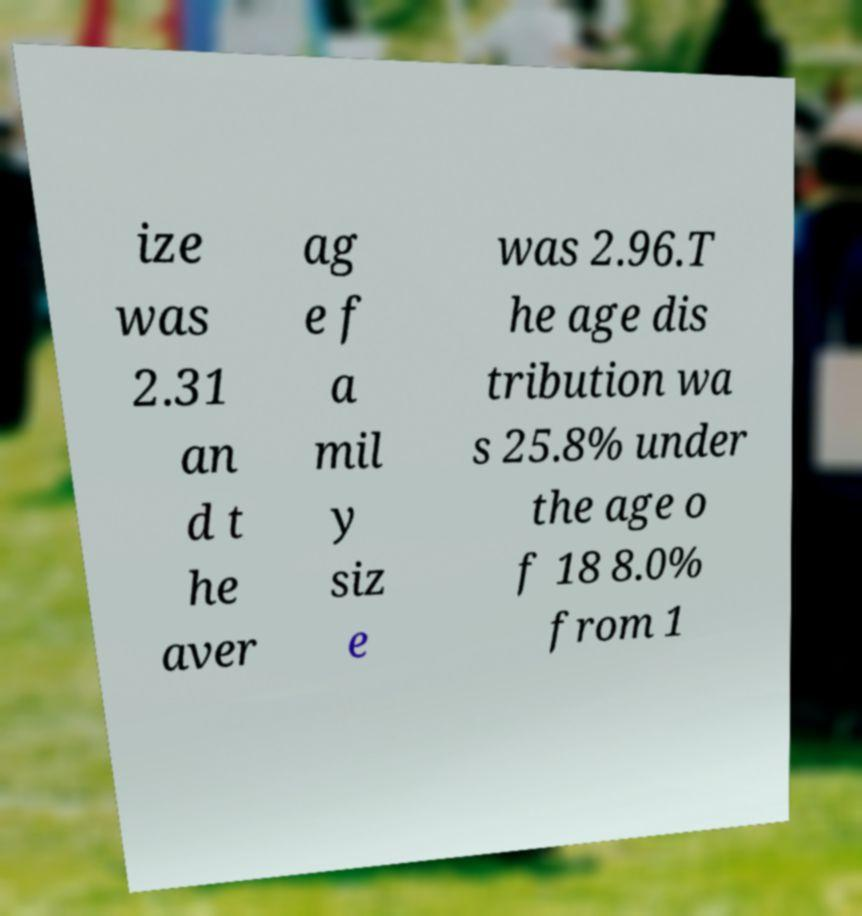Could you extract and type out the text from this image? ize was 2.31 an d t he aver ag e f a mil y siz e was 2.96.T he age dis tribution wa s 25.8% under the age o f 18 8.0% from 1 